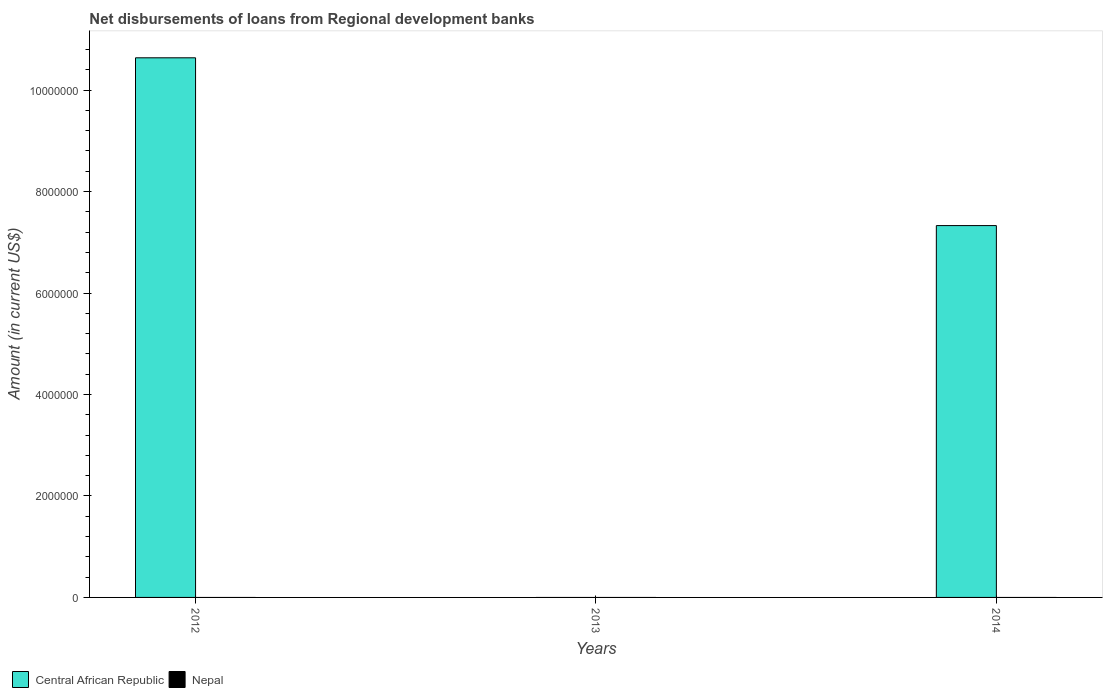Across all years, what is the maximum amount of disbursements of loans from regional development banks in Central African Republic?
Your response must be concise. 1.06e+07. Across all years, what is the minimum amount of disbursements of loans from regional development banks in Central African Republic?
Your response must be concise. 0. In which year was the amount of disbursements of loans from regional development banks in Central African Republic maximum?
Your answer should be compact. 2012. What is the total amount of disbursements of loans from regional development banks in Central African Republic in the graph?
Offer a terse response. 1.80e+07. What is the difference between the amount of disbursements of loans from regional development banks in Central African Republic in 2012 and that in 2014?
Offer a terse response. 3.31e+06. What is the difference between the amount of disbursements of loans from regional development banks in Central African Republic in 2012 and the amount of disbursements of loans from regional development banks in Nepal in 2013?
Your answer should be compact. 1.06e+07. What is the average amount of disbursements of loans from regional development banks in Nepal per year?
Give a very brief answer. 0. What is the ratio of the amount of disbursements of loans from regional development banks in Central African Republic in 2012 to that in 2014?
Ensure brevity in your answer.  1.45. Is the amount of disbursements of loans from regional development banks in Central African Republic in 2012 less than that in 2014?
Your response must be concise. No. What is the difference between the highest and the lowest amount of disbursements of loans from regional development banks in Central African Republic?
Give a very brief answer. 1.06e+07. Are all the bars in the graph horizontal?
Your answer should be very brief. No. Where does the legend appear in the graph?
Ensure brevity in your answer.  Bottom left. How many legend labels are there?
Your answer should be compact. 2. How are the legend labels stacked?
Your answer should be very brief. Horizontal. What is the title of the graph?
Offer a very short reply. Net disbursements of loans from Regional development banks. What is the Amount (in current US$) of Central African Republic in 2012?
Your answer should be very brief. 1.06e+07. What is the Amount (in current US$) in Nepal in 2012?
Your response must be concise. 0. What is the Amount (in current US$) in Central African Republic in 2013?
Your answer should be compact. 0. What is the Amount (in current US$) of Central African Republic in 2014?
Ensure brevity in your answer.  7.33e+06. Across all years, what is the maximum Amount (in current US$) in Central African Republic?
Make the answer very short. 1.06e+07. What is the total Amount (in current US$) in Central African Republic in the graph?
Make the answer very short. 1.80e+07. What is the total Amount (in current US$) in Nepal in the graph?
Your answer should be compact. 0. What is the difference between the Amount (in current US$) of Central African Republic in 2012 and that in 2014?
Give a very brief answer. 3.31e+06. What is the average Amount (in current US$) of Central African Republic per year?
Your answer should be very brief. 5.99e+06. What is the average Amount (in current US$) of Nepal per year?
Provide a short and direct response. 0. What is the ratio of the Amount (in current US$) of Central African Republic in 2012 to that in 2014?
Make the answer very short. 1.45. What is the difference between the highest and the lowest Amount (in current US$) of Central African Republic?
Provide a succinct answer. 1.06e+07. 